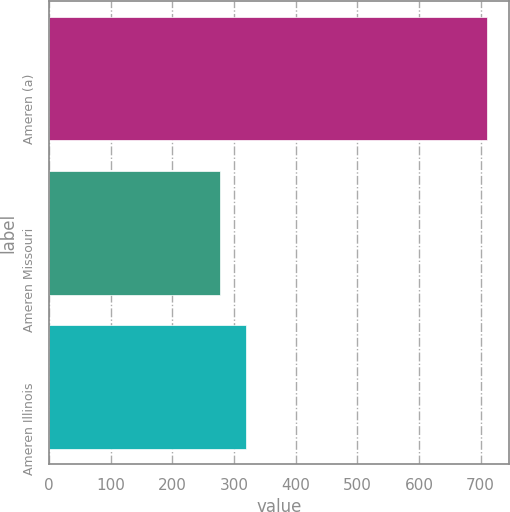<chart> <loc_0><loc_0><loc_500><loc_500><bar_chart><fcel>Ameren (a)<fcel>Ameren Missouri<fcel>Ameren Illinois<nl><fcel>710<fcel>277<fcel>320.3<nl></chart> 